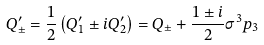<formula> <loc_0><loc_0><loc_500><loc_500>Q _ { \pm } ^ { \prime } = \frac { 1 } { 2 } \left ( Q _ { 1 } ^ { \prime } \pm i Q _ { 2 } ^ { \prime } \right ) = Q _ { \pm } + \frac { 1 \pm i } 2 \sigma ^ { 3 } p _ { 3 }</formula> 